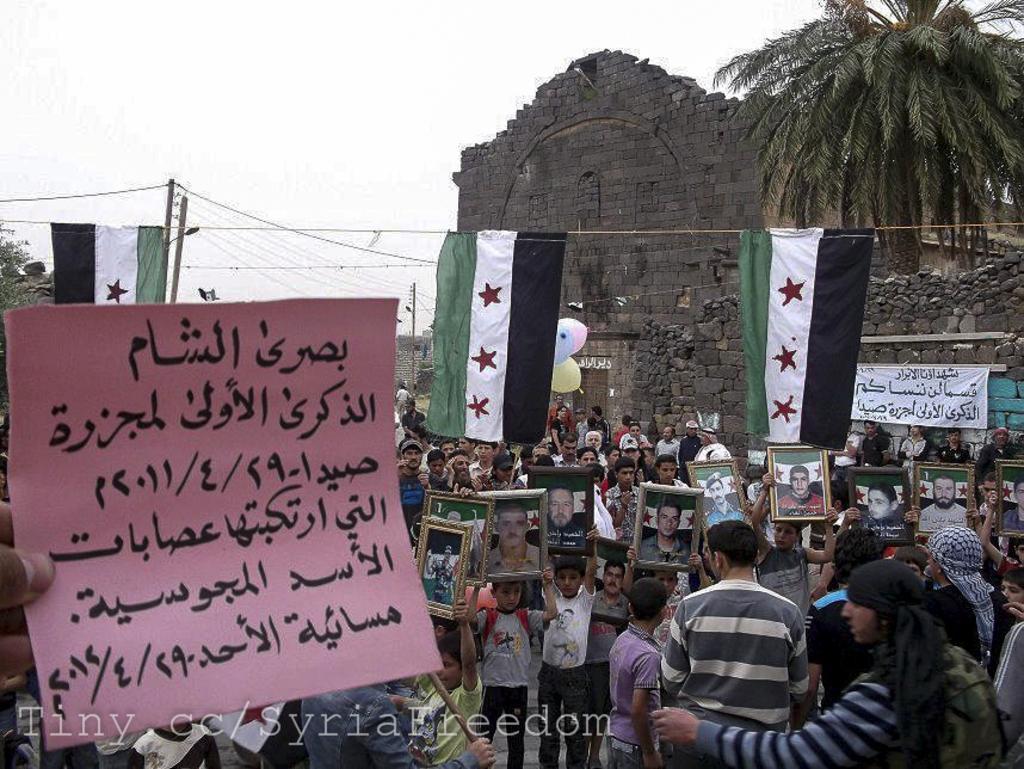Describe this image in one or two sentences. This picture is clicked outside the city. At the bottom of the picture, we see children standing on the road. Most of them are holding photo frames in their hands. On the left side, we see a pink color chart with text written in Urdu language. Behind them, we see a tree and a castle. In the background, we see street lights, electric poles and trees. At the top of the picture, we see the sky. 